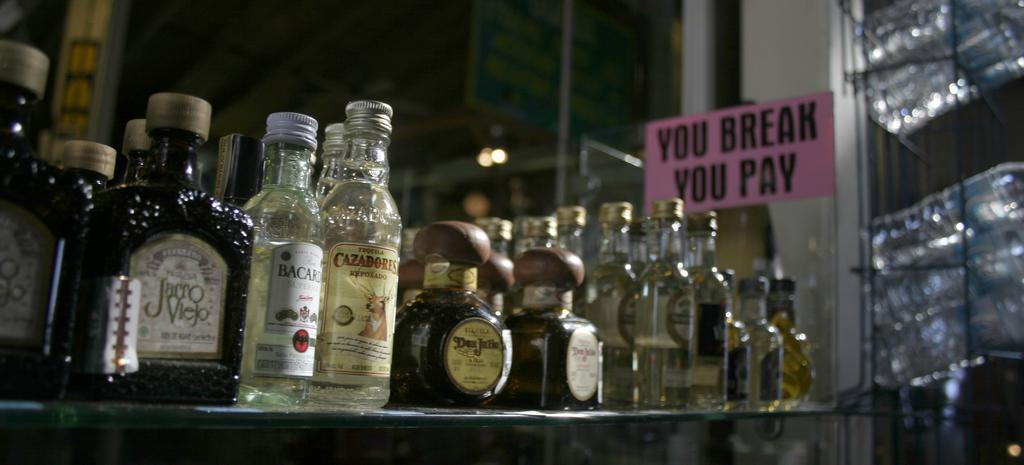Provide a one-sentence caption for the provided image. A bunch of liquor bottles are aligned on a shelf next to a sign saying you break you pay. 